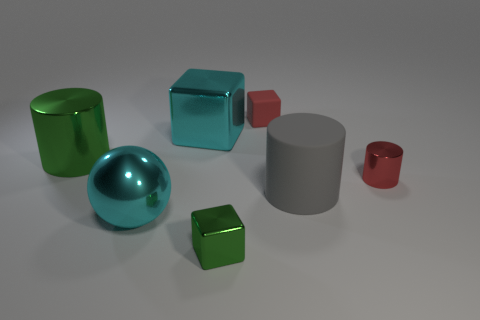There is a tiny cylinder that is the same color as the rubber block; what is its material?
Ensure brevity in your answer.  Metal. There is a gray thing that is the same size as the green metal cylinder; what is its material?
Offer a very short reply. Rubber. What number of green shiny things have the same shape as the gray rubber object?
Your answer should be very brief. 1. There is a green cylinder that is made of the same material as the big block; what is its size?
Offer a very short reply. Large. There is a tiny object that is both behind the large gray matte cylinder and on the left side of the small cylinder; what material is it?
Provide a succinct answer. Rubber. What number of cyan balls are the same size as the green block?
Provide a short and direct response. 0. There is another green object that is the same shape as the tiny rubber object; what is it made of?
Your answer should be very brief. Metal. How many objects are big cyan objects behind the large shiny cylinder or large things behind the red metallic thing?
Your response must be concise. 2. Does the large green shiny thing have the same shape as the tiny metallic thing that is right of the green block?
Make the answer very short. Yes. What shape is the big shiny thing behind the shiny cylinder that is behind the red object that is in front of the small red matte cube?
Your answer should be very brief. Cube. 